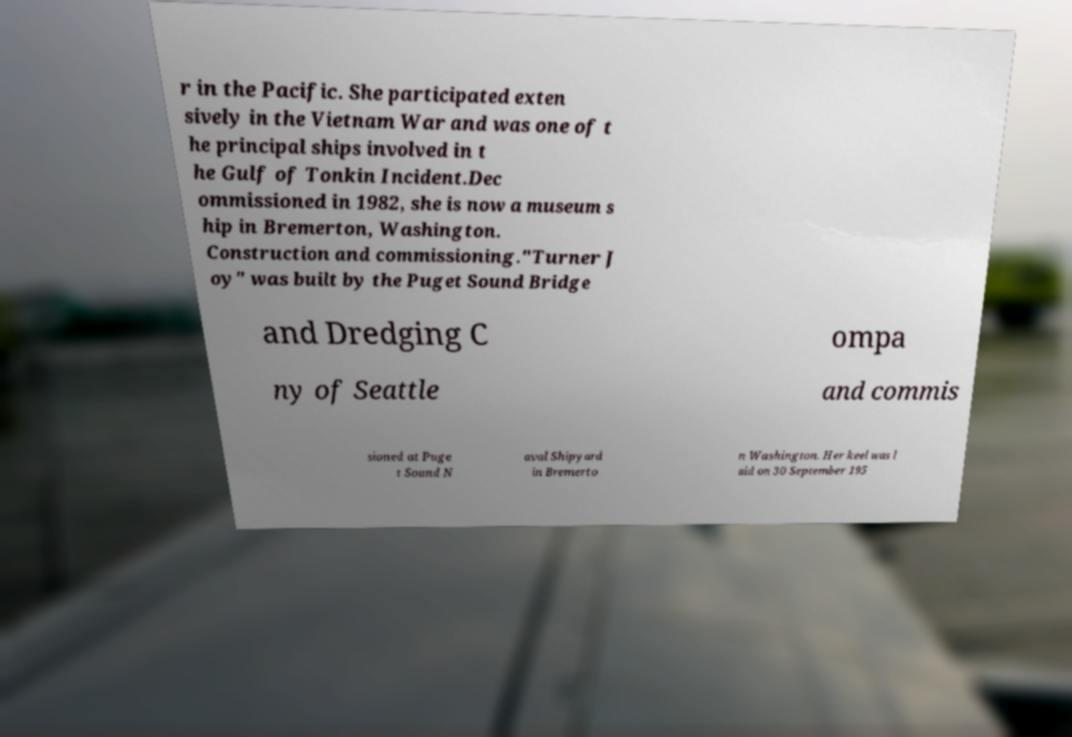What messages or text are displayed in this image? I need them in a readable, typed format. r in the Pacific. She participated exten sively in the Vietnam War and was one of t he principal ships involved in t he Gulf of Tonkin Incident.Dec ommissioned in 1982, she is now a museum s hip in Bremerton, Washington. Construction and commissioning."Turner J oy" was built by the Puget Sound Bridge and Dredging C ompa ny of Seattle and commis sioned at Puge t Sound N aval Shipyard in Bremerto n Washington. Her keel was l aid on 30 September 195 